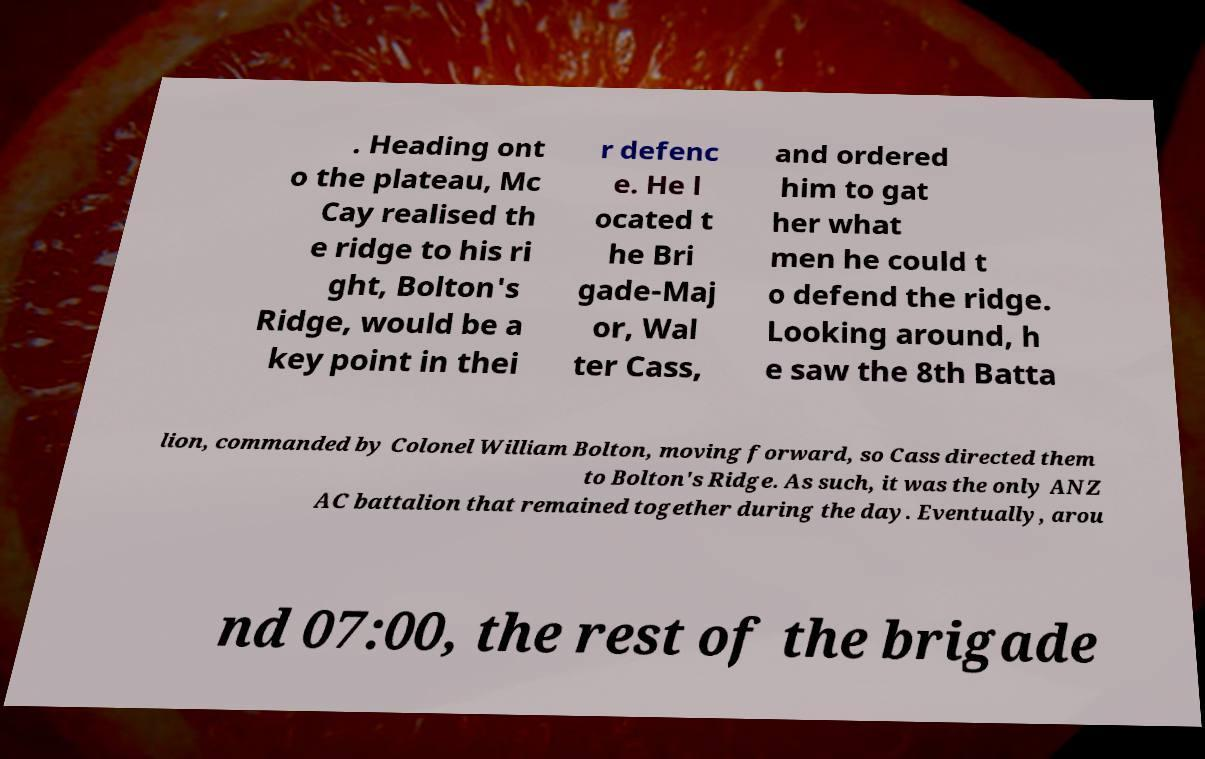Please read and relay the text visible in this image. What does it say? . Heading ont o the plateau, Mc Cay realised th e ridge to his ri ght, Bolton's Ridge, would be a key point in thei r defenc e. He l ocated t he Bri gade-Maj or, Wal ter Cass, and ordered him to gat her what men he could t o defend the ridge. Looking around, h e saw the 8th Batta lion, commanded by Colonel William Bolton, moving forward, so Cass directed them to Bolton's Ridge. As such, it was the only ANZ AC battalion that remained together during the day. Eventually, arou nd 07:00, the rest of the brigade 